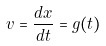Convert formula to latex. <formula><loc_0><loc_0><loc_500><loc_500>v = \frac { d x } { d t } = g ( t )</formula> 